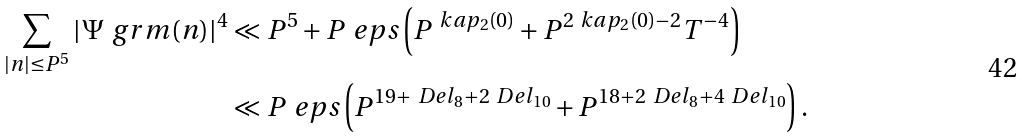<formula> <loc_0><loc_0><loc_500><loc_500>\sum _ { | n | \leq P ^ { 5 } } | \Psi _ { \ } g r m ( n ) | ^ { 4 } & \ll P ^ { 5 } + P ^ { \ } e p s \left ( P ^ { \ k a p _ { 2 } ( 0 ) } + P ^ { 2 \ k a p _ { 2 } ( 0 ) - 2 } T ^ { - 4 } \right ) \\ & \ll P ^ { \ } e p s \left ( P ^ { 1 9 + \ D e l _ { 8 } + 2 \ D e l _ { 1 0 } } + P ^ { 1 8 + 2 \ D e l _ { 8 } + 4 \ D e l _ { 1 0 } } \right ) .</formula> 